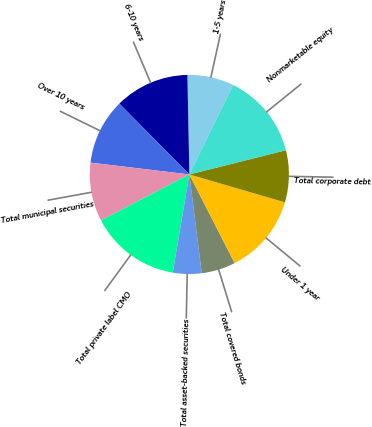Convert chart to OTSL. <chart><loc_0><loc_0><loc_500><loc_500><pie_chart><fcel>1-5 years<fcel>6-10 years<fcel>Over 10 years<fcel>Total municipal securities<fcel>Total private label CMO<fcel>Total asset-backed securities<fcel>Total covered bonds<fcel>Under 1 year<fcel>Total corporate debt<fcel>Nonmarketable equity<nl><fcel>7.57%<fcel>12.09%<fcel>10.7%<fcel>9.53%<fcel>14.7%<fcel>4.66%<fcel>5.53%<fcel>12.96%<fcel>8.44%<fcel>13.83%<nl></chart> 